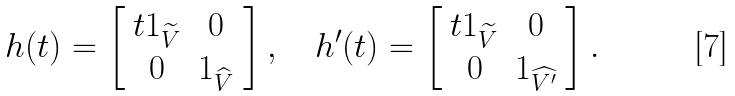<formula> <loc_0><loc_0><loc_500><loc_500>h ( t ) = \left [ \begin{array} { c c } t 1 _ { \widetilde { V } } & 0 \\ 0 & 1 _ { \widehat { V } } \end{array} \right ] , \quad h ^ { \prime } ( t ) = \left [ \begin{array} { c c } t 1 _ { \widetilde { V } } & 0 \\ 0 & 1 _ { \widehat { V ^ { \prime } } } \end{array} \right ] .</formula> 